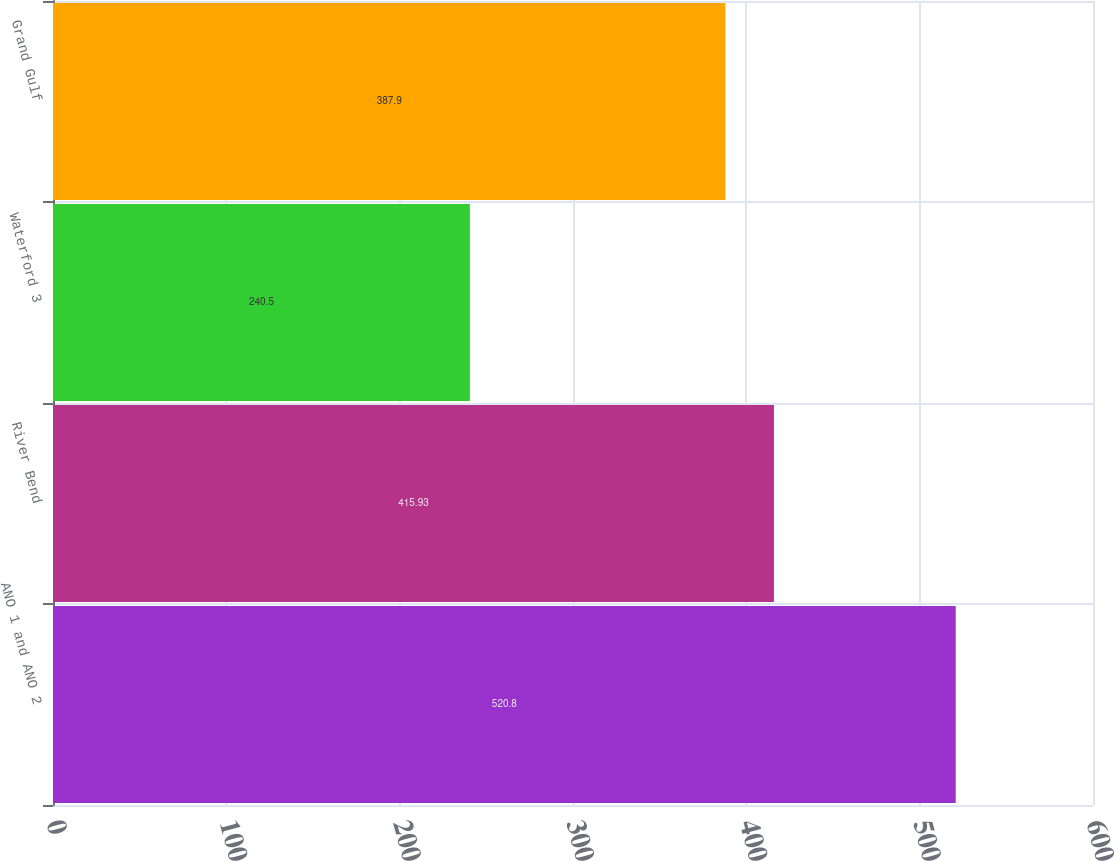<chart> <loc_0><loc_0><loc_500><loc_500><bar_chart><fcel>ANO 1 and ANO 2<fcel>River Bend<fcel>Waterford 3<fcel>Grand Gulf<nl><fcel>520.8<fcel>415.93<fcel>240.5<fcel>387.9<nl></chart> 